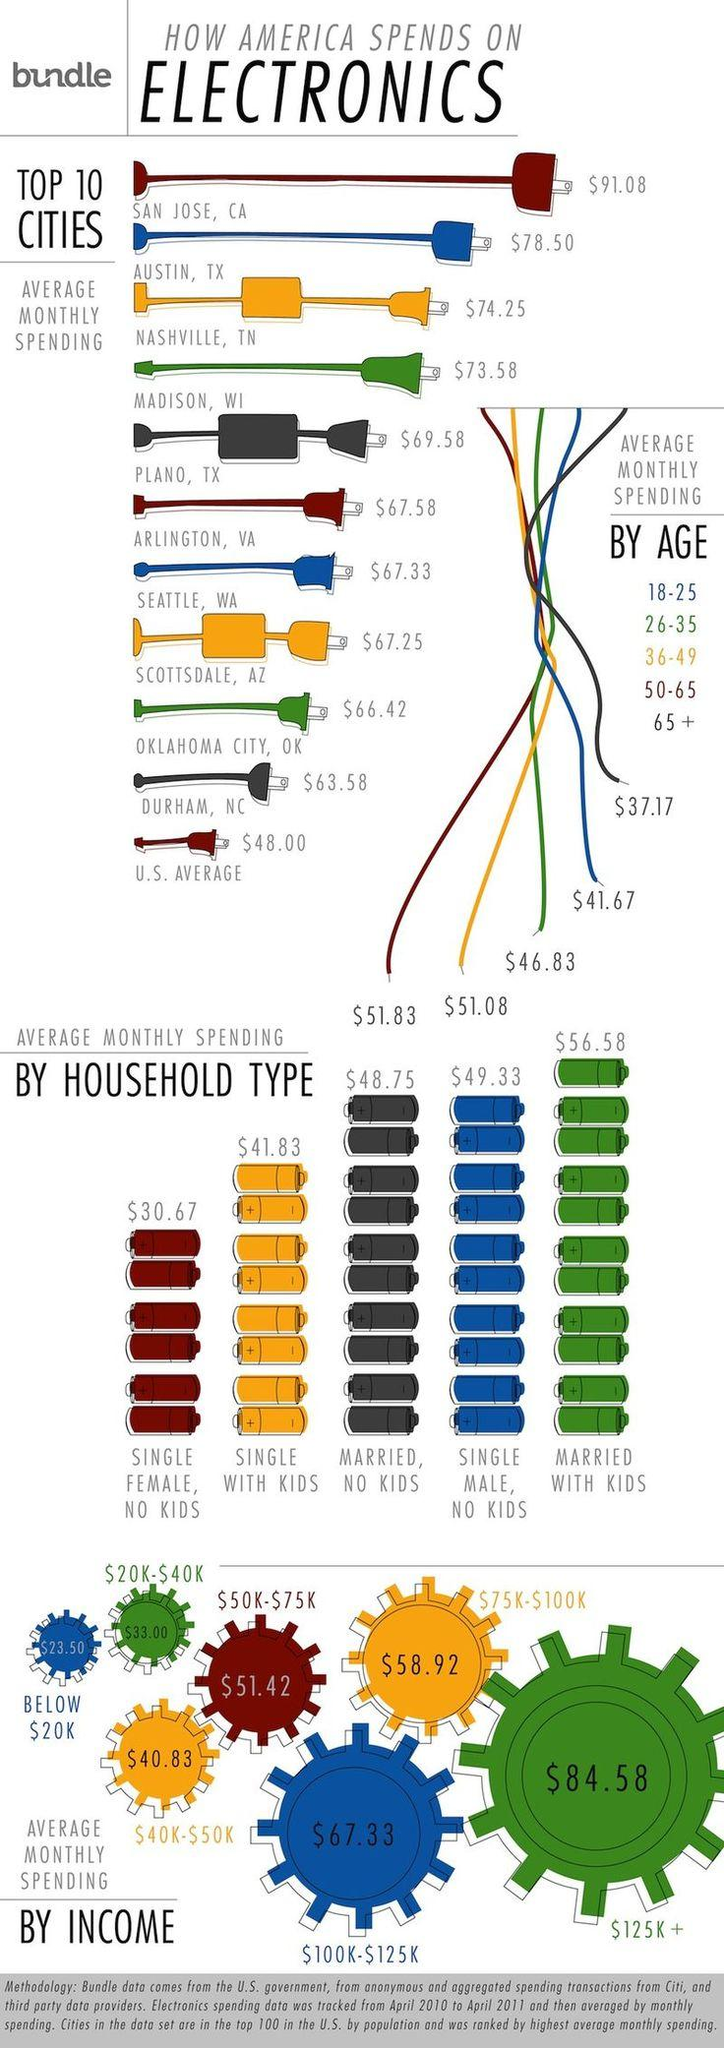Highlight a few significant elements in this photo. The average amount spent on electronics by the income group earning $30,000 per year is $33. Single women save more than single males by cutting down expenses on electronics, resulting in a savings of $18.33. The average total monthly spending in Austin and Plano is $146.08. The difference in the average monthly spending of a household with a married couple, with or without children, is $7.83. The average monthly spending of the age group 50-65 on electronics is $51.83. 